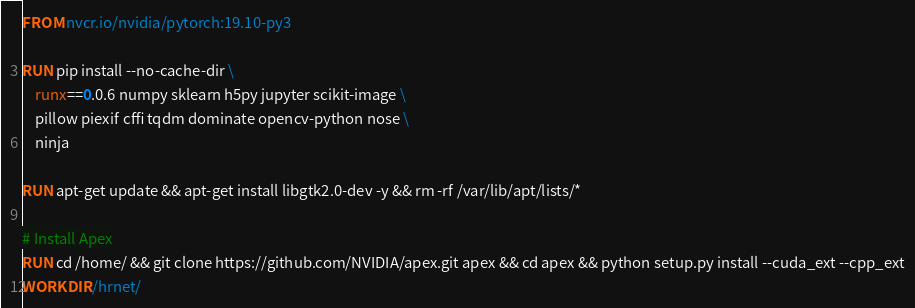Convert code to text. <code><loc_0><loc_0><loc_500><loc_500><_Dockerfile_>FROM nvcr.io/nvidia/pytorch:19.10-py3

RUN pip install --no-cache-dir \
    runx==0.0.6 numpy sklearn h5py jupyter scikit-image \
    pillow piexif cffi tqdm dominate opencv-python nose \
    ninja

RUN apt-get update && apt-get install libgtk2.0-dev -y && rm -rf /var/lib/apt/lists/*

# Install Apex
RUN cd /home/ && git clone https://github.com/NVIDIA/apex.git apex && cd apex && python setup.py install --cuda_ext --cpp_ext
WORKDIR /hrnet/

</code> 